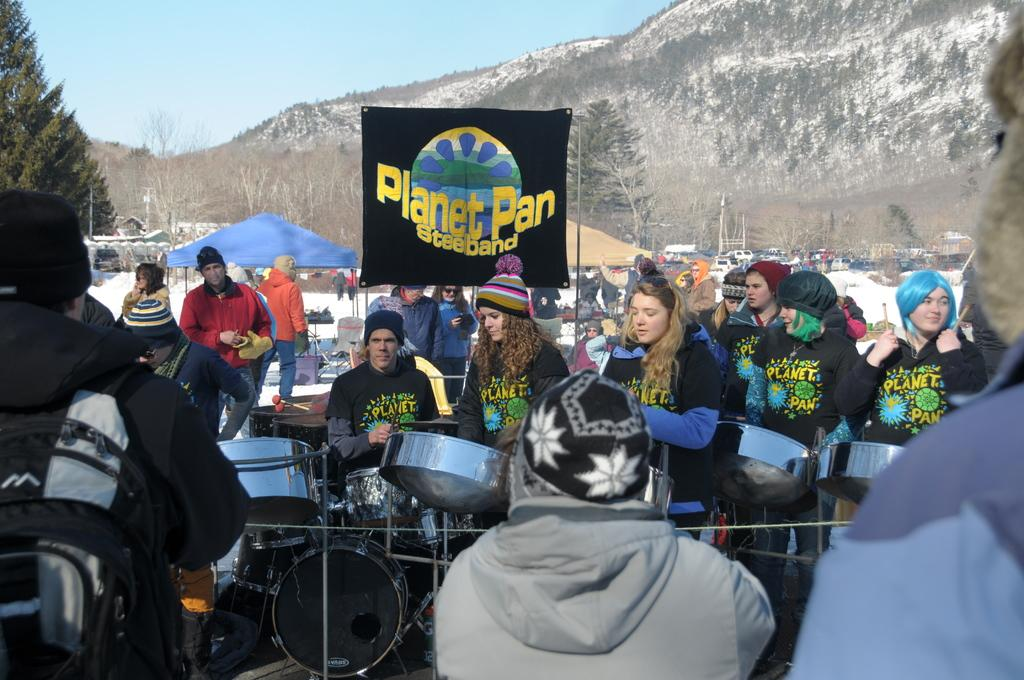How many persons are in the image? There are persons in the image, but the exact number is not specified. What are the persons doing in the image? Some of the persons are standing, and some are sitting. What can be seen in the background of the image? There is a banner, a tree, a mountain, and the sky visible in the background of the image. What type of game is being played by the persons in the image? There is no indication in the image that the persons are playing a game, so it cannot be determined from the picture. 